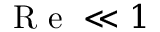Convert formula to latex. <formula><loc_0><loc_0><loc_500><loc_500>R e \ll 1</formula> 